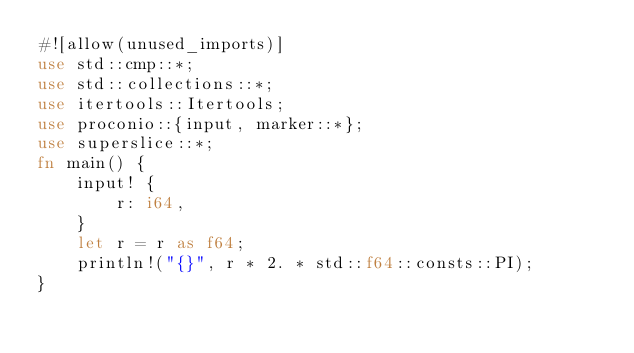<code> <loc_0><loc_0><loc_500><loc_500><_Rust_>#![allow(unused_imports)]
use std::cmp::*;
use std::collections::*;
use itertools::Itertools;
use proconio::{input, marker::*};
use superslice::*;
fn main() {
    input! {
        r: i64,
    }
    let r = r as f64;
    println!("{}", r * 2. * std::f64::consts::PI);
}
</code> 